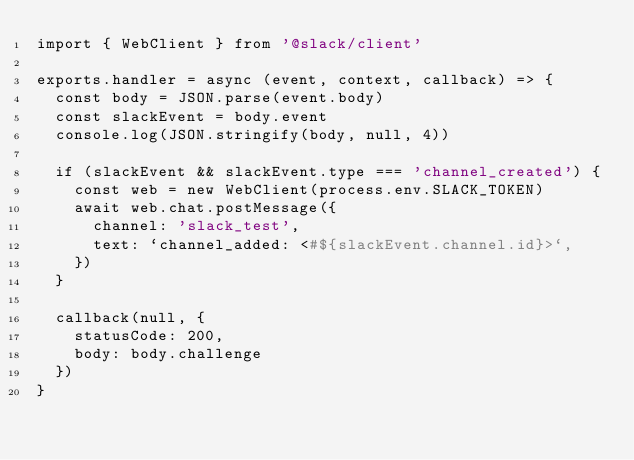Convert code to text. <code><loc_0><loc_0><loc_500><loc_500><_JavaScript_>import { WebClient } from '@slack/client'

exports.handler = async (event, context, callback) => {
  const body = JSON.parse(event.body)
  const slackEvent = body.event
  console.log(JSON.stringify(body, null, 4))

  if (slackEvent && slackEvent.type === 'channel_created') {
    const web = new WebClient(process.env.SLACK_TOKEN)
    await web.chat.postMessage({
      channel: 'slack_test',
      text: `channel_added: <#${slackEvent.channel.id}>`,
    })
  }

  callback(null, {
    statusCode: 200,
    body: body.challenge
  })
}</code> 